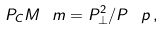<formula> <loc_0><loc_0><loc_500><loc_500>P _ { C } M ^ { \ } m = P _ { \perp } ^ { 2 } / P ^ { \ } p \, ,</formula> 